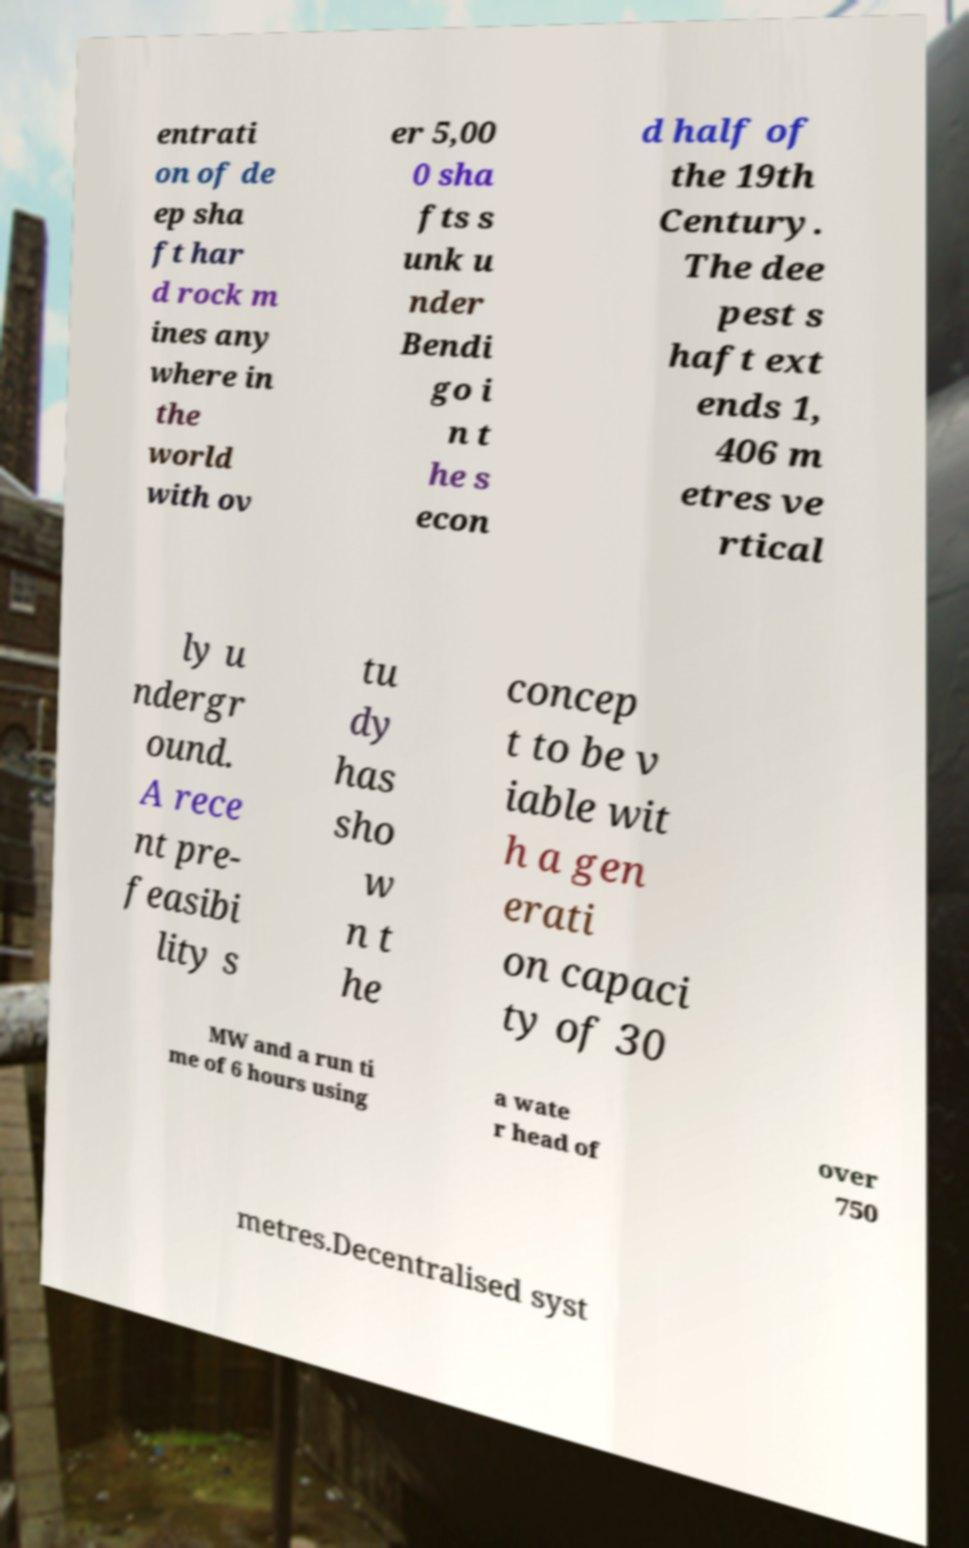Could you assist in decoding the text presented in this image and type it out clearly? entrati on of de ep sha ft har d rock m ines any where in the world with ov er 5,00 0 sha fts s unk u nder Bendi go i n t he s econ d half of the 19th Century. The dee pest s haft ext ends 1, 406 m etres ve rtical ly u ndergr ound. A rece nt pre- feasibi lity s tu dy has sho w n t he concep t to be v iable wit h a gen erati on capaci ty of 30 MW and a run ti me of 6 hours using a wate r head of over 750 metres.Decentralised syst 